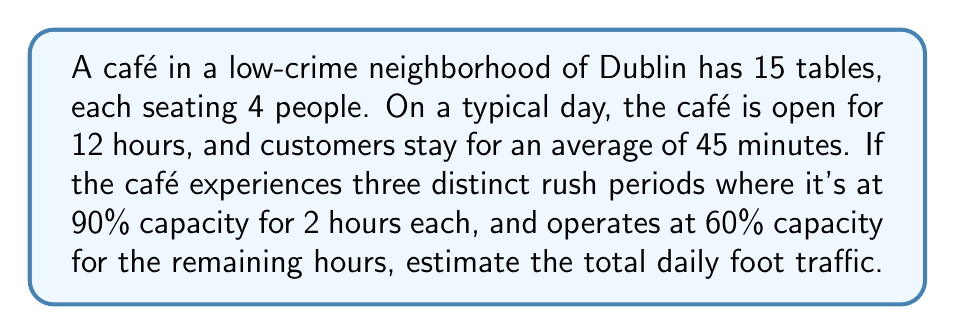What is the answer to this math problem? Let's break this down step-by-step:

1. Calculate the total seating capacity:
   $$ \text{Total seats} = 15 \text{ tables} \times 4 \text{ seats per table} = 60 \text{ seats} $$

2. Calculate the number of customer turnovers in an hour:
   $$ \text{Turnovers per hour} = \frac{60 \text{ minutes}}{45 \text{ minutes per customer}} = 1.33 $$

3. Calculate the capacity during rush periods (90% for 6 hours):
   $$ \text{Rush capacity} = 60 \text{ seats} \times 0.90 \times 6 \text{ hours} \times 1.33 \text{ turnovers} = 429.84 \text{ customers} $$

4. Calculate the capacity during non-rush periods (60% for 6 hours):
   $$ \text{Non-rush capacity} = 60 \text{ seats} \times 0.60 \times 6 \text{ hours} \times 1.33 \text{ turnovers} = 286.56 \text{ customers} $$

5. Sum up the total daily foot traffic:
   $$ \text{Total foot traffic} = 429.84 + 286.56 = 716.4 \text{ customers} $$

6. Round to the nearest whole number:
   $$ \text{Rounded foot traffic} = 716 \text{ customers} $$
Answer: 716 customers 